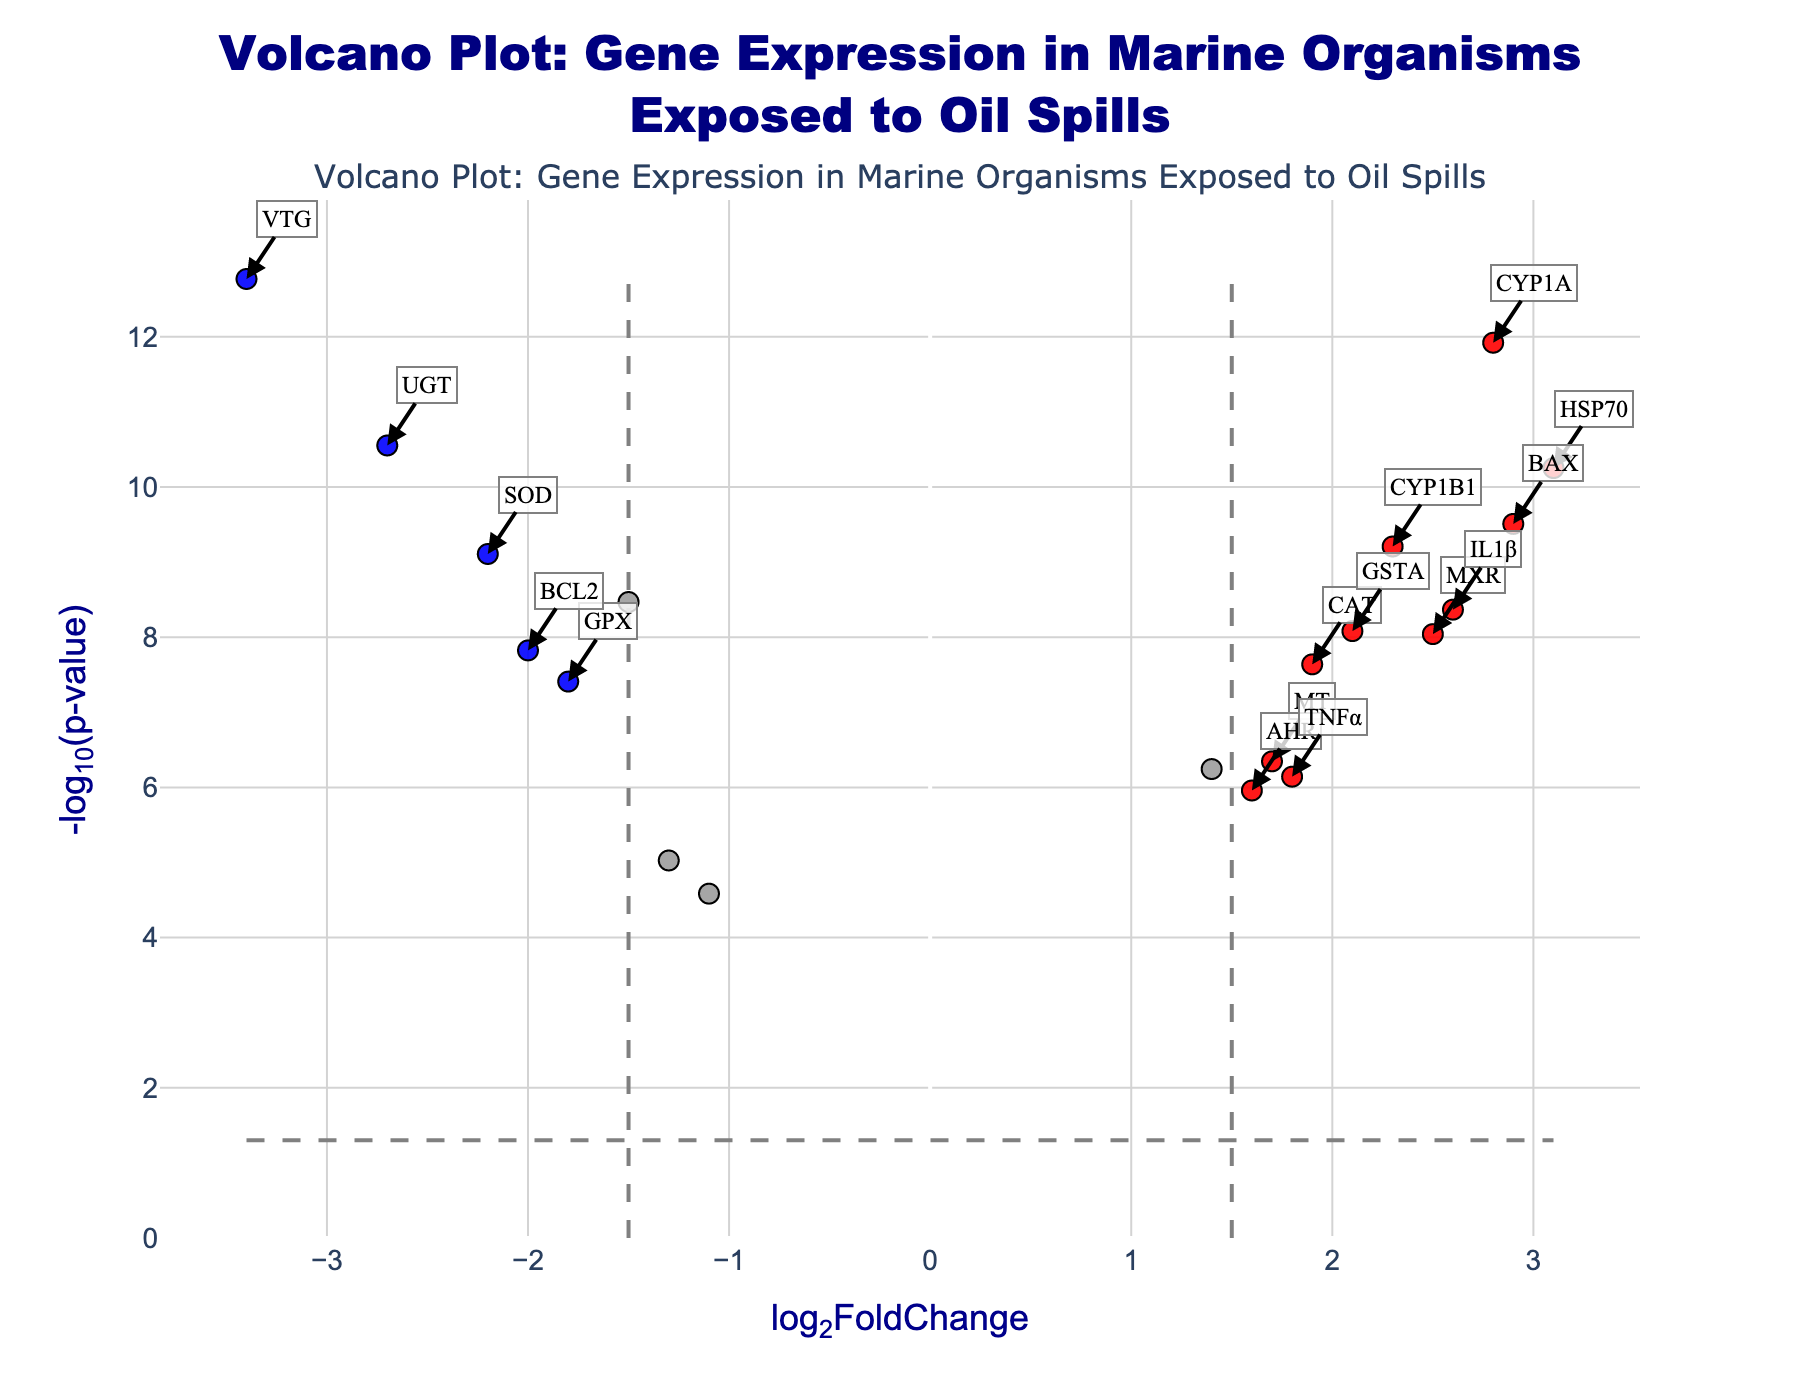What's the title of the plot? The title of the plot is typically found at the top of the figure, indicating the main subject or purpose of the plot. In this case, it reads "Volcano Plot: Gene Expression in Marine Organisms Exposed to Oil Spills".
Answer: Volcano Plot: Gene Expression in Marine Organisms Exposed to Oil Spills What are the axis labels? The x-axis label is "log2FoldChange" and the y-axis label is "-log10(p-value)". These labels are found beside the respective axes and describe what each axis represents.
Answer: log2FoldChange and -log10(p-value) What is the threshold for log2FoldChange? Looking at the vertical dashed lines, the threshold for log2FoldChange is ±1.5, indicating the cutoff values for determining if the genes are significantly regulated.
Answer: ±1.5 Which gene has the highest -log10(p-value)? To find this, look for the point that is highest on the y-axis. The highest point is for the gene VTG.
Answer: VTG Which genes are significantly up-regulated with a log2FoldChange greater than 2.5? To identify these genes, find the points on the right of the plot beyond the vertical line (log2FoldChange > 2.5) and below p-value threshold. The genes are CYP1A, HSP70, MXR, and IL1β.
Answer: CYP1A, HSP70, MXR, IL1β How many genes are classified as down-regulated? Down-regulated genes are those with a log2FoldChange less than -1.5 and a p-value below the threshold (blue points). Count the blue points: GST, SOD, VTG, GPX, UGT, BCL2. There are 6 genes.
Answer: 6 Which genes are near the threshold of -1.5 log2FoldChange? Identify the points close to the vertical dashed line at -1.5. The genes closest are GST and NRF2.
Answer: GST and NRF2 What is the difference between the log2FoldChange of the most up-regulated and the most down-regulated genes? The most up-regulated gene is HSP70 with a log2FoldChange of 3.1, and the most down-regulated gene is VTG with a log2FoldChange of -3.4. The difference is calculated as 3.1 - (-3.4) = 6.5.
Answer: 6.5 How many genes are classified as not significant? Count the gray points on the plot, which represent the genes classified as not significant. These genes do not meet either fold-change or p-value thresholds.
Answer: 2 What are the log2FoldChange and -log10(p-value) for gene BAX? The coordinates for gene BAX can be read off the plot. For BAX, log2FoldChange is 2.9 and -log10(p-value) is log10(3.1e-10). Calculate -log10(3.1e-10) to get approximately 9.5.
Answer: log2FoldChange: 2.9, -log10(p-value): 9.5 